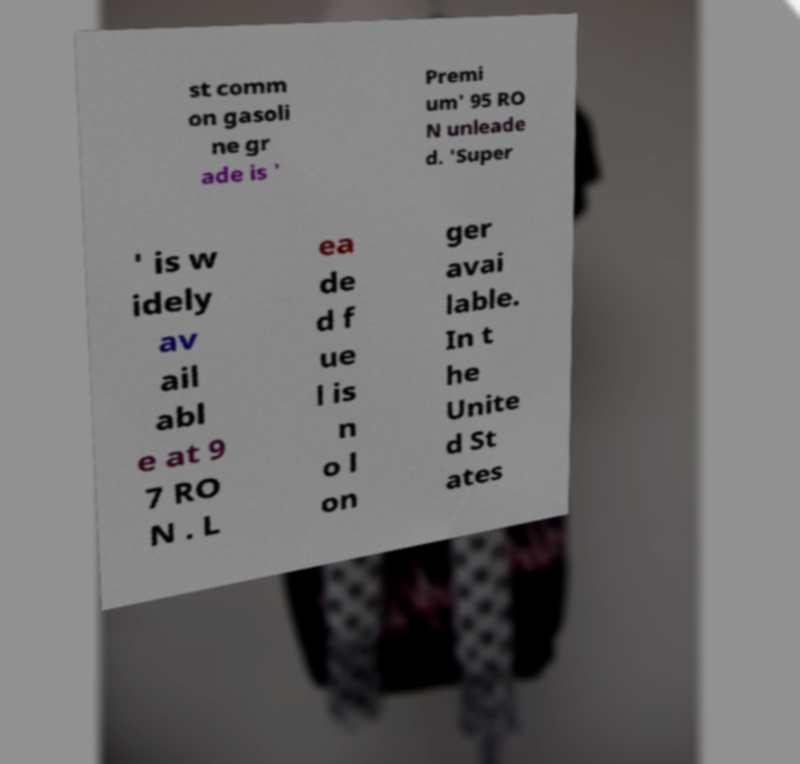Can you read and provide the text displayed in the image?This photo seems to have some interesting text. Can you extract and type it out for me? st comm on gasoli ne gr ade is ' Premi um' 95 RO N unleade d. 'Super ' is w idely av ail abl e at 9 7 RO N . L ea de d f ue l is n o l on ger avai lable. In t he Unite d St ates 